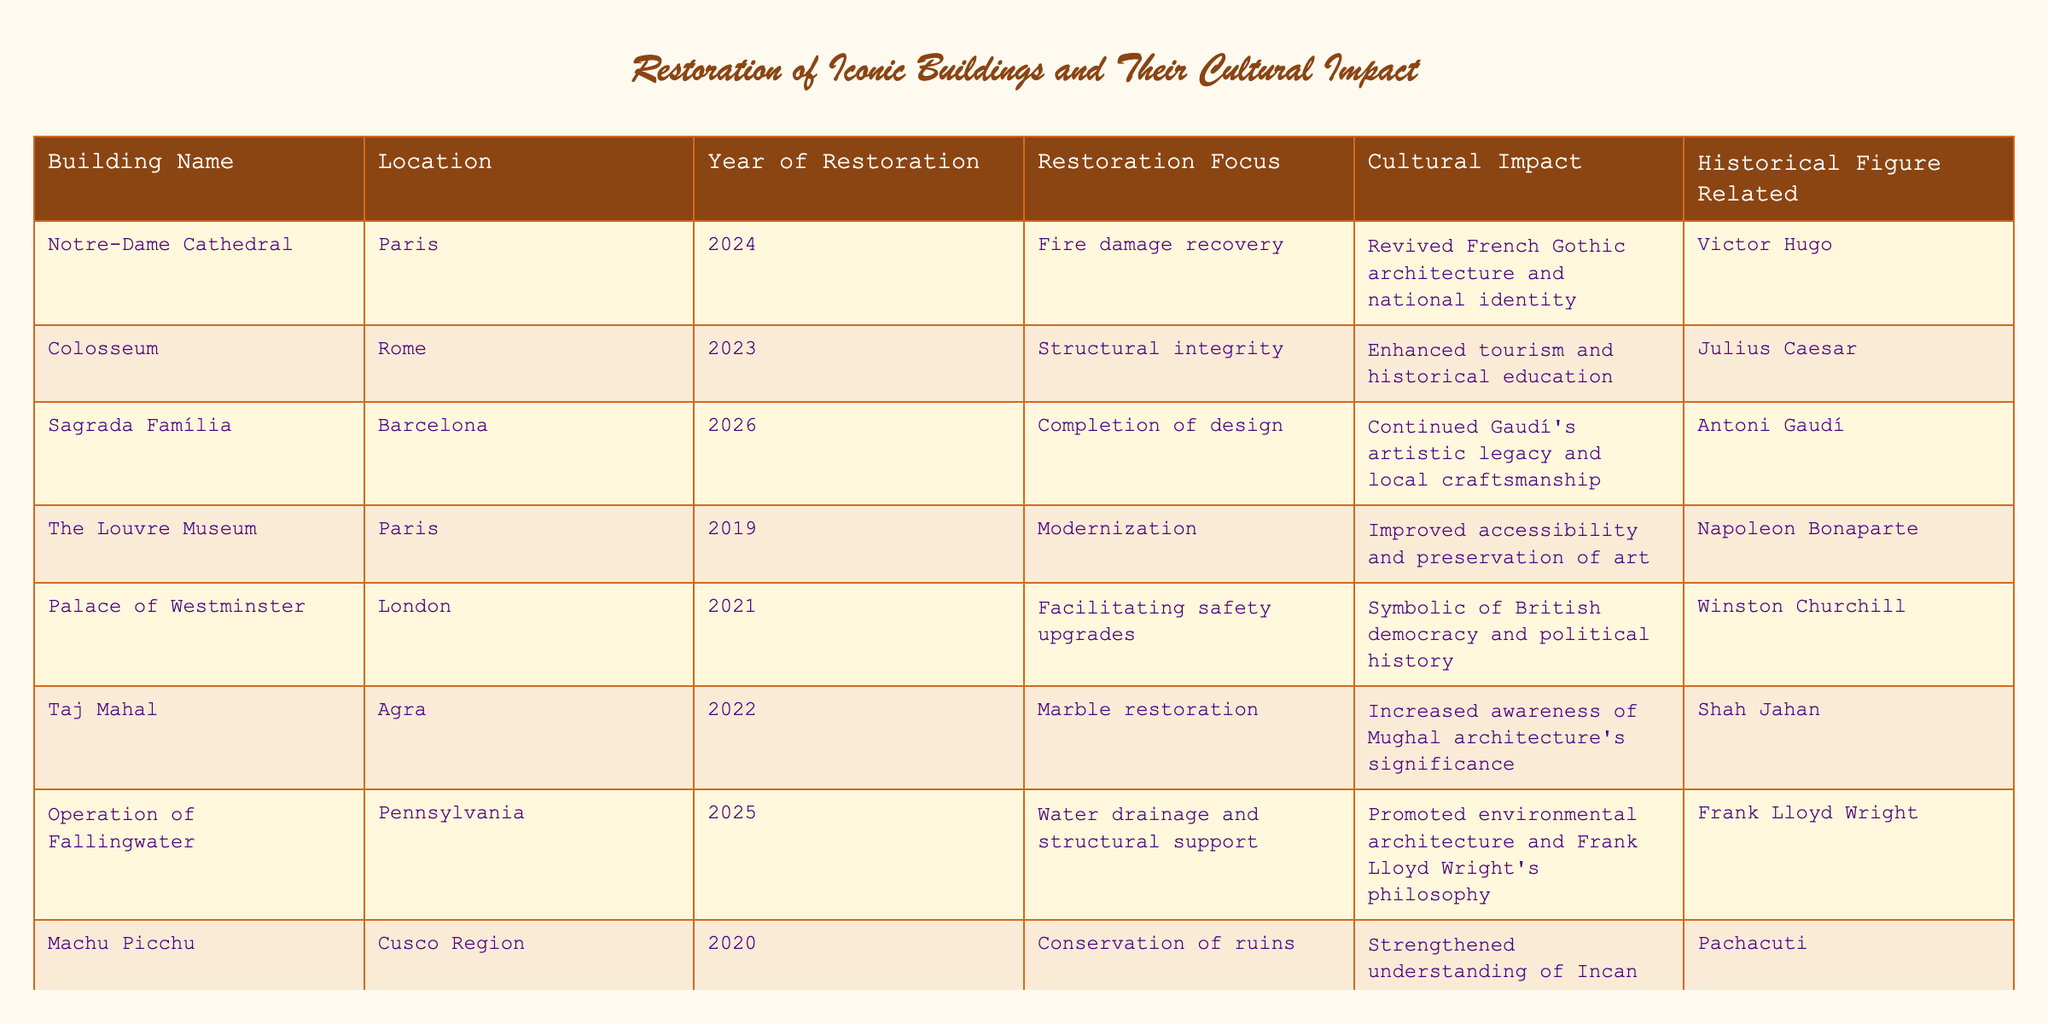What building was restored in 2024? The table lists the restoration years for each building, and by scanning the column for "Year of Restoration," we see that Notre-Dame Cathedral is associated with the year 2024.
Answer: Notre-Dame Cathedral Which building's restoration focused on modernizing the structure? Looking at the "Restoration Focus" column, The Louvre Museum's focus is noted as "Modernization," which directly answers the question.
Answer: The Louvre Museum What is the cultural impact of restoring the Colosseum? The table details that the cultural impact of the Colosseum restoration is "Enhanced tourism and historical education," which is specified next to the building's name.
Answer: Enhanced tourism and historical education How many buildings were restored after the year 2020? To find this, we count the rows representing the years after 2020: there are six buildings listed with restoration years of 2021, 2022, 2023, 2024, 2025, and 2026 (Palace of Westminster, Taj Mahal, Colosseum, Notre-Dame Cathedral, Fallingwater, Sagrada Família).
Answer: Six buildings Is the restoration of Machu Picchu related to a historical figure? The table has a column titled "Historical Figure Related," which shows that Machu Picchu is related to Pachacuti. This confirms the restoration is linked to a historical figure.
Answer: Yes Which building relates to Frank Lloyd Wright and what was its restoration focus? Searching the table, we find Fallingwater is associated with Frank Lloyd Wright. Its restoration focus is specified as "Water drainage and structural support," providing a complete answer.
Answer: Fallingwater; Water drainage and structural support What was the earliest year of restoration mentioned in the table? Reviewing the "Year of Restoration" column, we notice the earliest year listed is 2019, corresponding to The Louvre Museum.
Answer: 2019 Identify the building whose restoration increased awareness of Mughal architecture. The Taj Mahal is noted for its cultural impact in the table, specifically stating it "Increased awareness of Mughal architecture's significance."
Answer: Taj Mahal What is the average year of restoration for the buildings listed? The years of restoration are 2019, 2020, 2021, 2022, 2023, 2024, 2025, and 2026. Their sum is 2019 + 2020 + 2021 + 2022 + 2023 + 2024 + 2025 + 2026 = 16160. There are 8 buildings leading to an average of 16160 / 8 = 2020.
Answer: 2020 